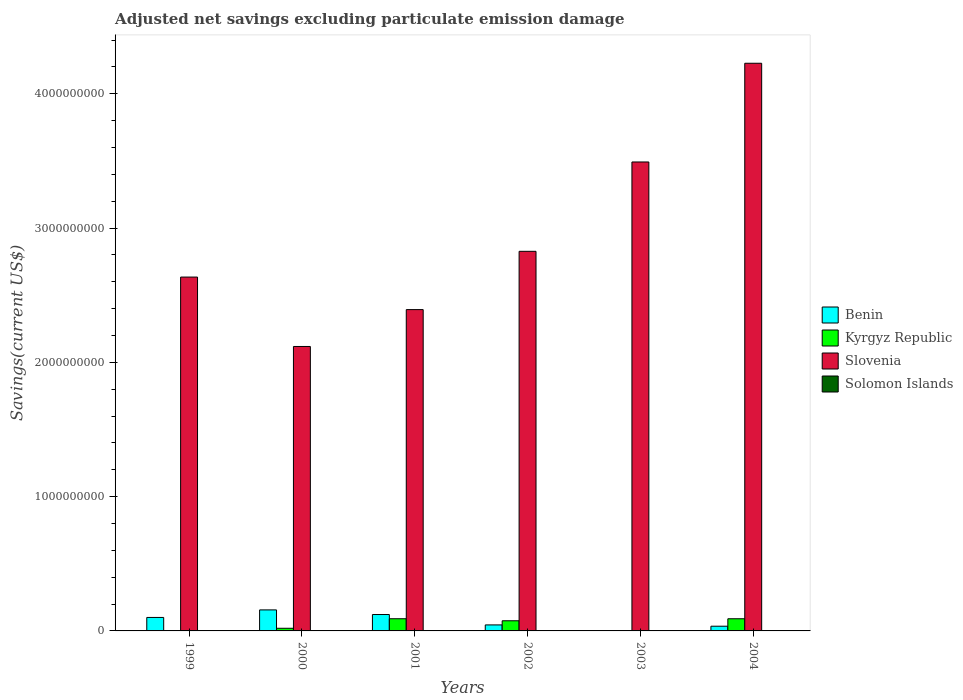How many groups of bars are there?
Your answer should be compact. 6. Are the number of bars on each tick of the X-axis equal?
Your answer should be compact. No. How many bars are there on the 2nd tick from the right?
Offer a very short reply. 2. What is the label of the 3rd group of bars from the left?
Your response must be concise. 2001. What is the adjusted net savings in Slovenia in 2002?
Your response must be concise. 2.83e+09. Across all years, what is the maximum adjusted net savings in Kyrgyz Republic?
Your answer should be very brief. 9.07e+07. In which year was the adjusted net savings in Benin maximum?
Provide a succinct answer. 2000. What is the total adjusted net savings in Solomon Islands in the graph?
Provide a short and direct response. 9.45e+05. What is the difference between the adjusted net savings in Slovenia in 2000 and that in 2002?
Provide a succinct answer. -7.09e+08. What is the difference between the adjusted net savings in Kyrgyz Republic in 2001 and the adjusted net savings in Benin in 2004?
Your answer should be compact. 5.57e+07. What is the average adjusted net savings in Slovenia per year?
Provide a succinct answer. 2.95e+09. In the year 2000, what is the difference between the adjusted net savings in Slovenia and adjusted net savings in Kyrgyz Republic?
Make the answer very short. 2.10e+09. What is the ratio of the adjusted net savings in Slovenia in 2003 to that in 2004?
Give a very brief answer. 0.83. Is the adjusted net savings in Slovenia in 2001 less than that in 2004?
Your response must be concise. Yes. What is the difference between the highest and the second highest adjusted net savings in Kyrgyz Republic?
Ensure brevity in your answer.  9.00e+04. What is the difference between the highest and the lowest adjusted net savings in Benin?
Provide a succinct answer. 1.57e+08. Is it the case that in every year, the sum of the adjusted net savings in Benin and adjusted net savings in Slovenia is greater than the adjusted net savings in Solomon Islands?
Give a very brief answer. Yes. Are all the bars in the graph horizontal?
Offer a terse response. No. What is the difference between two consecutive major ticks on the Y-axis?
Offer a very short reply. 1.00e+09. Are the values on the major ticks of Y-axis written in scientific E-notation?
Ensure brevity in your answer.  No. Does the graph contain any zero values?
Ensure brevity in your answer.  Yes. Does the graph contain grids?
Your answer should be compact. No. How many legend labels are there?
Your response must be concise. 4. What is the title of the graph?
Make the answer very short. Adjusted net savings excluding particulate emission damage. Does "St. Martin (French part)" appear as one of the legend labels in the graph?
Make the answer very short. No. What is the label or title of the Y-axis?
Keep it short and to the point. Savings(current US$). What is the Savings(current US$) in Benin in 1999?
Offer a terse response. 1.00e+08. What is the Savings(current US$) of Slovenia in 1999?
Offer a terse response. 2.64e+09. What is the Savings(current US$) of Benin in 2000?
Provide a short and direct response. 1.57e+08. What is the Savings(current US$) in Kyrgyz Republic in 2000?
Your answer should be compact. 1.97e+07. What is the Savings(current US$) in Slovenia in 2000?
Offer a very short reply. 2.12e+09. What is the Savings(current US$) in Solomon Islands in 2000?
Make the answer very short. 0. What is the Savings(current US$) in Benin in 2001?
Your response must be concise. 1.22e+08. What is the Savings(current US$) in Kyrgyz Republic in 2001?
Keep it short and to the point. 9.07e+07. What is the Savings(current US$) of Slovenia in 2001?
Your answer should be very brief. 2.39e+09. What is the Savings(current US$) in Benin in 2002?
Keep it short and to the point. 4.47e+07. What is the Savings(current US$) in Kyrgyz Republic in 2002?
Your answer should be compact. 7.56e+07. What is the Savings(current US$) of Slovenia in 2002?
Offer a very short reply. 2.83e+09. What is the Savings(current US$) in Kyrgyz Republic in 2003?
Offer a terse response. 0. What is the Savings(current US$) of Slovenia in 2003?
Provide a succinct answer. 3.49e+09. What is the Savings(current US$) of Solomon Islands in 2003?
Your response must be concise. 9.45e+05. What is the Savings(current US$) in Benin in 2004?
Provide a short and direct response. 3.50e+07. What is the Savings(current US$) in Kyrgyz Republic in 2004?
Ensure brevity in your answer.  9.06e+07. What is the Savings(current US$) of Slovenia in 2004?
Offer a very short reply. 4.23e+09. What is the Savings(current US$) in Solomon Islands in 2004?
Ensure brevity in your answer.  0. Across all years, what is the maximum Savings(current US$) of Benin?
Ensure brevity in your answer.  1.57e+08. Across all years, what is the maximum Savings(current US$) of Kyrgyz Republic?
Make the answer very short. 9.07e+07. Across all years, what is the maximum Savings(current US$) in Slovenia?
Provide a short and direct response. 4.23e+09. Across all years, what is the maximum Savings(current US$) in Solomon Islands?
Your answer should be very brief. 9.45e+05. Across all years, what is the minimum Savings(current US$) of Benin?
Provide a succinct answer. 0. Across all years, what is the minimum Savings(current US$) in Kyrgyz Republic?
Provide a succinct answer. 0. Across all years, what is the minimum Savings(current US$) of Slovenia?
Your response must be concise. 2.12e+09. What is the total Savings(current US$) in Benin in the graph?
Your answer should be very brief. 4.59e+08. What is the total Savings(current US$) of Kyrgyz Republic in the graph?
Keep it short and to the point. 2.77e+08. What is the total Savings(current US$) in Slovenia in the graph?
Offer a very short reply. 1.77e+1. What is the total Savings(current US$) of Solomon Islands in the graph?
Offer a very short reply. 9.45e+05. What is the difference between the Savings(current US$) in Benin in 1999 and that in 2000?
Offer a terse response. -5.62e+07. What is the difference between the Savings(current US$) of Slovenia in 1999 and that in 2000?
Your answer should be very brief. 5.17e+08. What is the difference between the Savings(current US$) in Benin in 1999 and that in 2001?
Your answer should be very brief. -2.17e+07. What is the difference between the Savings(current US$) of Slovenia in 1999 and that in 2001?
Provide a short and direct response. 2.42e+08. What is the difference between the Savings(current US$) in Benin in 1999 and that in 2002?
Your response must be concise. 5.56e+07. What is the difference between the Savings(current US$) in Slovenia in 1999 and that in 2002?
Provide a succinct answer. -1.92e+08. What is the difference between the Savings(current US$) of Slovenia in 1999 and that in 2003?
Give a very brief answer. -8.57e+08. What is the difference between the Savings(current US$) in Benin in 1999 and that in 2004?
Make the answer very short. 6.53e+07. What is the difference between the Savings(current US$) of Slovenia in 1999 and that in 2004?
Ensure brevity in your answer.  -1.59e+09. What is the difference between the Savings(current US$) of Benin in 2000 and that in 2001?
Ensure brevity in your answer.  3.45e+07. What is the difference between the Savings(current US$) of Kyrgyz Republic in 2000 and that in 2001?
Make the answer very short. -7.10e+07. What is the difference between the Savings(current US$) of Slovenia in 2000 and that in 2001?
Make the answer very short. -2.75e+08. What is the difference between the Savings(current US$) in Benin in 2000 and that in 2002?
Your response must be concise. 1.12e+08. What is the difference between the Savings(current US$) in Kyrgyz Republic in 2000 and that in 2002?
Your response must be concise. -5.59e+07. What is the difference between the Savings(current US$) of Slovenia in 2000 and that in 2002?
Offer a very short reply. -7.09e+08. What is the difference between the Savings(current US$) of Slovenia in 2000 and that in 2003?
Provide a succinct answer. -1.37e+09. What is the difference between the Savings(current US$) in Benin in 2000 and that in 2004?
Offer a terse response. 1.22e+08. What is the difference between the Savings(current US$) of Kyrgyz Republic in 2000 and that in 2004?
Make the answer very short. -7.09e+07. What is the difference between the Savings(current US$) of Slovenia in 2000 and that in 2004?
Offer a terse response. -2.11e+09. What is the difference between the Savings(current US$) in Benin in 2001 and that in 2002?
Your response must be concise. 7.74e+07. What is the difference between the Savings(current US$) of Kyrgyz Republic in 2001 and that in 2002?
Offer a terse response. 1.51e+07. What is the difference between the Savings(current US$) of Slovenia in 2001 and that in 2002?
Your answer should be very brief. -4.34e+08. What is the difference between the Savings(current US$) in Slovenia in 2001 and that in 2003?
Offer a very short reply. -1.10e+09. What is the difference between the Savings(current US$) of Benin in 2001 and that in 2004?
Keep it short and to the point. 8.70e+07. What is the difference between the Savings(current US$) in Kyrgyz Republic in 2001 and that in 2004?
Provide a short and direct response. 9.00e+04. What is the difference between the Savings(current US$) of Slovenia in 2001 and that in 2004?
Give a very brief answer. -1.83e+09. What is the difference between the Savings(current US$) in Slovenia in 2002 and that in 2003?
Your response must be concise. -6.65e+08. What is the difference between the Savings(current US$) in Benin in 2002 and that in 2004?
Your answer should be compact. 9.67e+06. What is the difference between the Savings(current US$) in Kyrgyz Republic in 2002 and that in 2004?
Offer a terse response. -1.50e+07. What is the difference between the Savings(current US$) of Slovenia in 2002 and that in 2004?
Make the answer very short. -1.40e+09. What is the difference between the Savings(current US$) in Slovenia in 2003 and that in 2004?
Make the answer very short. -7.35e+08. What is the difference between the Savings(current US$) in Benin in 1999 and the Savings(current US$) in Kyrgyz Republic in 2000?
Provide a succinct answer. 8.06e+07. What is the difference between the Savings(current US$) of Benin in 1999 and the Savings(current US$) of Slovenia in 2000?
Give a very brief answer. -2.02e+09. What is the difference between the Savings(current US$) of Benin in 1999 and the Savings(current US$) of Kyrgyz Republic in 2001?
Offer a very short reply. 9.63e+06. What is the difference between the Savings(current US$) in Benin in 1999 and the Savings(current US$) in Slovenia in 2001?
Give a very brief answer. -2.29e+09. What is the difference between the Savings(current US$) of Benin in 1999 and the Savings(current US$) of Kyrgyz Republic in 2002?
Make the answer very short. 2.47e+07. What is the difference between the Savings(current US$) of Benin in 1999 and the Savings(current US$) of Slovenia in 2002?
Your answer should be compact. -2.73e+09. What is the difference between the Savings(current US$) of Benin in 1999 and the Savings(current US$) of Slovenia in 2003?
Provide a succinct answer. -3.39e+09. What is the difference between the Savings(current US$) in Benin in 1999 and the Savings(current US$) in Solomon Islands in 2003?
Ensure brevity in your answer.  9.94e+07. What is the difference between the Savings(current US$) of Slovenia in 1999 and the Savings(current US$) of Solomon Islands in 2003?
Offer a terse response. 2.63e+09. What is the difference between the Savings(current US$) of Benin in 1999 and the Savings(current US$) of Kyrgyz Republic in 2004?
Your response must be concise. 9.72e+06. What is the difference between the Savings(current US$) of Benin in 1999 and the Savings(current US$) of Slovenia in 2004?
Ensure brevity in your answer.  -4.13e+09. What is the difference between the Savings(current US$) of Benin in 2000 and the Savings(current US$) of Kyrgyz Republic in 2001?
Your answer should be compact. 6.59e+07. What is the difference between the Savings(current US$) of Benin in 2000 and the Savings(current US$) of Slovenia in 2001?
Your response must be concise. -2.24e+09. What is the difference between the Savings(current US$) in Kyrgyz Republic in 2000 and the Savings(current US$) in Slovenia in 2001?
Offer a very short reply. -2.37e+09. What is the difference between the Savings(current US$) of Benin in 2000 and the Savings(current US$) of Kyrgyz Republic in 2002?
Your answer should be compact. 8.10e+07. What is the difference between the Savings(current US$) of Benin in 2000 and the Savings(current US$) of Slovenia in 2002?
Offer a terse response. -2.67e+09. What is the difference between the Savings(current US$) in Kyrgyz Republic in 2000 and the Savings(current US$) in Slovenia in 2002?
Give a very brief answer. -2.81e+09. What is the difference between the Savings(current US$) of Benin in 2000 and the Savings(current US$) of Slovenia in 2003?
Provide a succinct answer. -3.34e+09. What is the difference between the Savings(current US$) in Benin in 2000 and the Savings(current US$) in Solomon Islands in 2003?
Provide a succinct answer. 1.56e+08. What is the difference between the Savings(current US$) of Kyrgyz Republic in 2000 and the Savings(current US$) of Slovenia in 2003?
Offer a terse response. -3.47e+09. What is the difference between the Savings(current US$) of Kyrgyz Republic in 2000 and the Savings(current US$) of Solomon Islands in 2003?
Make the answer very short. 1.88e+07. What is the difference between the Savings(current US$) in Slovenia in 2000 and the Savings(current US$) in Solomon Islands in 2003?
Ensure brevity in your answer.  2.12e+09. What is the difference between the Savings(current US$) in Benin in 2000 and the Savings(current US$) in Kyrgyz Republic in 2004?
Offer a very short reply. 6.60e+07. What is the difference between the Savings(current US$) of Benin in 2000 and the Savings(current US$) of Slovenia in 2004?
Keep it short and to the point. -4.07e+09. What is the difference between the Savings(current US$) of Kyrgyz Republic in 2000 and the Savings(current US$) of Slovenia in 2004?
Give a very brief answer. -4.21e+09. What is the difference between the Savings(current US$) of Benin in 2001 and the Savings(current US$) of Kyrgyz Republic in 2002?
Offer a very short reply. 4.65e+07. What is the difference between the Savings(current US$) in Benin in 2001 and the Savings(current US$) in Slovenia in 2002?
Provide a short and direct response. -2.70e+09. What is the difference between the Savings(current US$) of Kyrgyz Republic in 2001 and the Savings(current US$) of Slovenia in 2002?
Provide a succinct answer. -2.74e+09. What is the difference between the Savings(current US$) of Benin in 2001 and the Savings(current US$) of Slovenia in 2003?
Give a very brief answer. -3.37e+09. What is the difference between the Savings(current US$) of Benin in 2001 and the Savings(current US$) of Solomon Islands in 2003?
Your answer should be compact. 1.21e+08. What is the difference between the Savings(current US$) of Kyrgyz Republic in 2001 and the Savings(current US$) of Slovenia in 2003?
Your answer should be very brief. -3.40e+09. What is the difference between the Savings(current US$) in Kyrgyz Republic in 2001 and the Savings(current US$) in Solomon Islands in 2003?
Make the answer very short. 8.98e+07. What is the difference between the Savings(current US$) of Slovenia in 2001 and the Savings(current US$) of Solomon Islands in 2003?
Your response must be concise. 2.39e+09. What is the difference between the Savings(current US$) in Benin in 2001 and the Savings(current US$) in Kyrgyz Republic in 2004?
Your answer should be very brief. 3.15e+07. What is the difference between the Savings(current US$) of Benin in 2001 and the Savings(current US$) of Slovenia in 2004?
Keep it short and to the point. -4.11e+09. What is the difference between the Savings(current US$) of Kyrgyz Republic in 2001 and the Savings(current US$) of Slovenia in 2004?
Provide a short and direct response. -4.14e+09. What is the difference between the Savings(current US$) in Benin in 2002 and the Savings(current US$) in Slovenia in 2003?
Give a very brief answer. -3.45e+09. What is the difference between the Savings(current US$) of Benin in 2002 and the Savings(current US$) of Solomon Islands in 2003?
Provide a succinct answer. 4.38e+07. What is the difference between the Savings(current US$) of Kyrgyz Republic in 2002 and the Savings(current US$) of Slovenia in 2003?
Your answer should be very brief. -3.42e+09. What is the difference between the Savings(current US$) in Kyrgyz Republic in 2002 and the Savings(current US$) in Solomon Islands in 2003?
Keep it short and to the point. 7.47e+07. What is the difference between the Savings(current US$) in Slovenia in 2002 and the Savings(current US$) in Solomon Islands in 2003?
Offer a very short reply. 2.83e+09. What is the difference between the Savings(current US$) in Benin in 2002 and the Savings(current US$) in Kyrgyz Republic in 2004?
Your answer should be very brief. -4.59e+07. What is the difference between the Savings(current US$) of Benin in 2002 and the Savings(current US$) of Slovenia in 2004?
Keep it short and to the point. -4.18e+09. What is the difference between the Savings(current US$) of Kyrgyz Republic in 2002 and the Savings(current US$) of Slovenia in 2004?
Offer a very short reply. -4.15e+09. What is the average Savings(current US$) in Benin per year?
Your answer should be very brief. 7.65e+07. What is the average Savings(current US$) of Kyrgyz Republic per year?
Your answer should be very brief. 4.61e+07. What is the average Savings(current US$) in Slovenia per year?
Provide a succinct answer. 2.95e+09. What is the average Savings(current US$) of Solomon Islands per year?
Keep it short and to the point. 1.58e+05. In the year 1999, what is the difference between the Savings(current US$) of Benin and Savings(current US$) of Slovenia?
Offer a terse response. -2.53e+09. In the year 2000, what is the difference between the Savings(current US$) in Benin and Savings(current US$) in Kyrgyz Republic?
Provide a short and direct response. 1.37e+08. In the year 2000, what is the difference between the Savings(current US$) in Benin and Savings(current US$) in Slovenia?
Your answer should be compact. -1.96e+09. In the year 2000, what is the difference between the Savings(current US$) in Kyrgyz Republic and Savings(current US$) in Slovenia?
Keep it short and to the point. -2.10e+09. In the year 2001, what is the difference between the Savings(current US$) of Benin and Savings(current US$) of Kyrgyz Republic?
Ensure brevity in your answer.  3.14e+07. In the year 2001, what is the difference between the Savings(current US$) of Benin and Savings(current US$) of Slovenia?
Provide a succinct answer. -2.27e+09. In the year 2001, what is the difference between the Savings(current US$) of Kyrgyz Republic and Savings(current US$) of Slovenia?
Provide a short and direct response. -2.30e+09. In the year 2002, what is the difference between the Savings(current US$) of Benin and Savings(current US$) of Kyrgyz Republic?
Offer a very short reply. -3.09e+07. In the year 2002, what is the difference between the Savings(current US$) of Benin and Savings(current US$) of Slovenia?
Give a very brief answer. -2.78e+09. In the year 2002, what is the difference between the Savings(current US$) in Kyrgyz Republic and Savings(current US$) in Slovenia?
Give a very brief answer. -2.75e+09. In the year 2003, what is the difference between the Savings(current US$) in Slovenia and Savings(current US$) in Solomon Islands?
Provide a short and direct response. 3.49e+09. In the year 2004, what is the difference between the Savings(current US$) in Benin and Savings(current US$) in Kyrgyz Republic?
Provide a succinct answer. -5.56e+07. In the year 2004, what is the difference between the Savings(current US$) in Benin and Savings(current US$) in Slovenia?
Your response must be concise. -4.19e+09. In the year 2004, what is the difference between the Savings(current US$) of Kyrgyz Republic and Savings(current US$) of Slovenia?
Keep it short and to the point. -4.14e+09. What is the ratio of the Savings(current US$) of Benin in 1999 to that in 2000?
Keep it short and to the point. 0.64. What is the ratio of the Savings(current US$) in Slovenia in 1999 to that in 2000?
Provide a succinct answer. 1.24. What is the ratio of the Savings(current US$) of Benin in 1999 to that in 2001?
Give a very brief answer. 0.82. What is the ratio of the Savings(current US$) in Slovenia in 1999 to that in 2001?
Your answer should be very brief. 1.1. What is the ratio of the Savings(current US$) of Benin in 1999 to that in 2002?
Keep it short and to the point. 2.24. What is the ratio of the Savings(current US$) of Slovenia in 1999 to that in 2002?
Make the answer very short. 0.93. What is the ratio of the Savings(current US$) in Slovenia in 1999 to that in 2003?
Your response must be concise. 0.75. What is the ratio of the Savings(current US$) in Benin in 1999 to that in 2004?
Offer a very short reply. 2.86. What is the ratio of the Savings(current US$) of Slovenia in 1999 to that in 2004?
Provide a succinct answer. 0.62. What is the ratio of the Savings(current US$) in Benin in 2000 to that in 2001?
Ensure brevity in your answer.  1.28. What is the ratio of the Savings(current US$) in Kyrgyz Republic in 2000 to that in 2001?
Your response must be concise. 0.22. What is the ratio of the Savings(current US$) in Slovenia in 2000 to that in 2001?
Offer a terse response. 0.89. What is the ratio of the Savings(current US$) in Benin in 2000 to that in 2002?
Offer a very short reply. 3.5. What is the ratio of the Savings(current US$) of Kyrgyz Republic in 2000 to that in 2002?
Your answer should be very brief. 0.26. What is the ratio of the Savings(current US$) in Slovenia in 2000 to that in 2002?
Provide a succinct answer. 0.75. What is the ratio of the Savings(current US$) in Slovenia in 2000 to that in 2003?
Ensure brevity in your answer.  0.61. What is the ratio of the Savings(current US$) of Benin in 2000 to that in 2004?
Provide a short and direct response. 4.47. What is the ratio of the Savings(current US$) of Kyrgyz Republic in 2000 to that in 2004?
Offer a terse response. 0.22. What is the ratio of the Savings(current US$) of Slovenia in 2000 to that in 2004?
Provide a short and direct response. 0.5. What is the ratio of the Savings(current US$) in Benin in 2001 to that in 2002?
Your answer should be very brief. 2.73. What is the ratio of the Savings(current US$) in Kyrgyz Republic in 2001 to that in 2002?
Offer a very short reply. 1.2. What is the ratio of the Savings(current US$) of Slovenia in 2001 to that in 2002?
Ensure brevity in your answer.  0.85. What is the ratio of the Savings(current US$) in Slovenia in 2001 to that in 2003?
Your answer should be very brief. 0.69. What is the ratio of the Savings(current US$) in Benin in 2001 to that in 2004?
Offer a terse response. 3.48. What is the ratio of the Savings(current US$) of Kyrgyz Republic in 2001 to that in 2004?
Your answer should be compact. 1. What is the ratio of the Savings(current US$) in Slovenia in 2001 to that in 2004?
Give a very brief answer. 0.57. What is the ratio of the Savings(current US$) in Slovenia in 2002 to that in 2003?
Provide a succinct answer. 0.81. What is the ratio of the Savings(current US$) in Benin in 2002 to that in 2004?
Ensure brevity in your answer.  1.28. What is the ratio of the Savings(current US$) in Kyrgyz Republic in 2002 to that in 2004?
Make the answer very short. 0.83. What is the ratio of the Savings(current US$) in Slovenia in 2002 to that in 2004?
Offer a terse response. 0.67. What is the ratio of the Savings(current US$) of Slovenia in 2003 to that in 2004?
Ensure brevity in your answer.  0.83. What is the difference between the highest and the second highest Savings(current US$) of Benin?
Provide a succinct answer. 3.45e+07. What is the difference between the highest and the second highest Savings(current US$) in Kyrgyz Republic?
Make the answer very short. 9.00e+04. What is the difference between the highest and the second highest Savings(current US$) of Slovenia?
Your answer should be very brief. 7.35e+08. What is the difference between the highest and the lowest Savings(current US$) of Benin?
Ensure brevity in your answer.  1.57e+08. What is the difference between the highest and the lowest Savings(current US$) in Kyrgyz Republic?
Provide a succinct answer. 9.07e+07. What is the difference between the highest and the lowest Savings(current US$) in Slovenia?
Ensure brevity in your answer.  2.11e+09. What is the difference between the highest and the lowest Savings(current US$) of Solomon Islands?
Make the answer very short. 9.45e+05. 